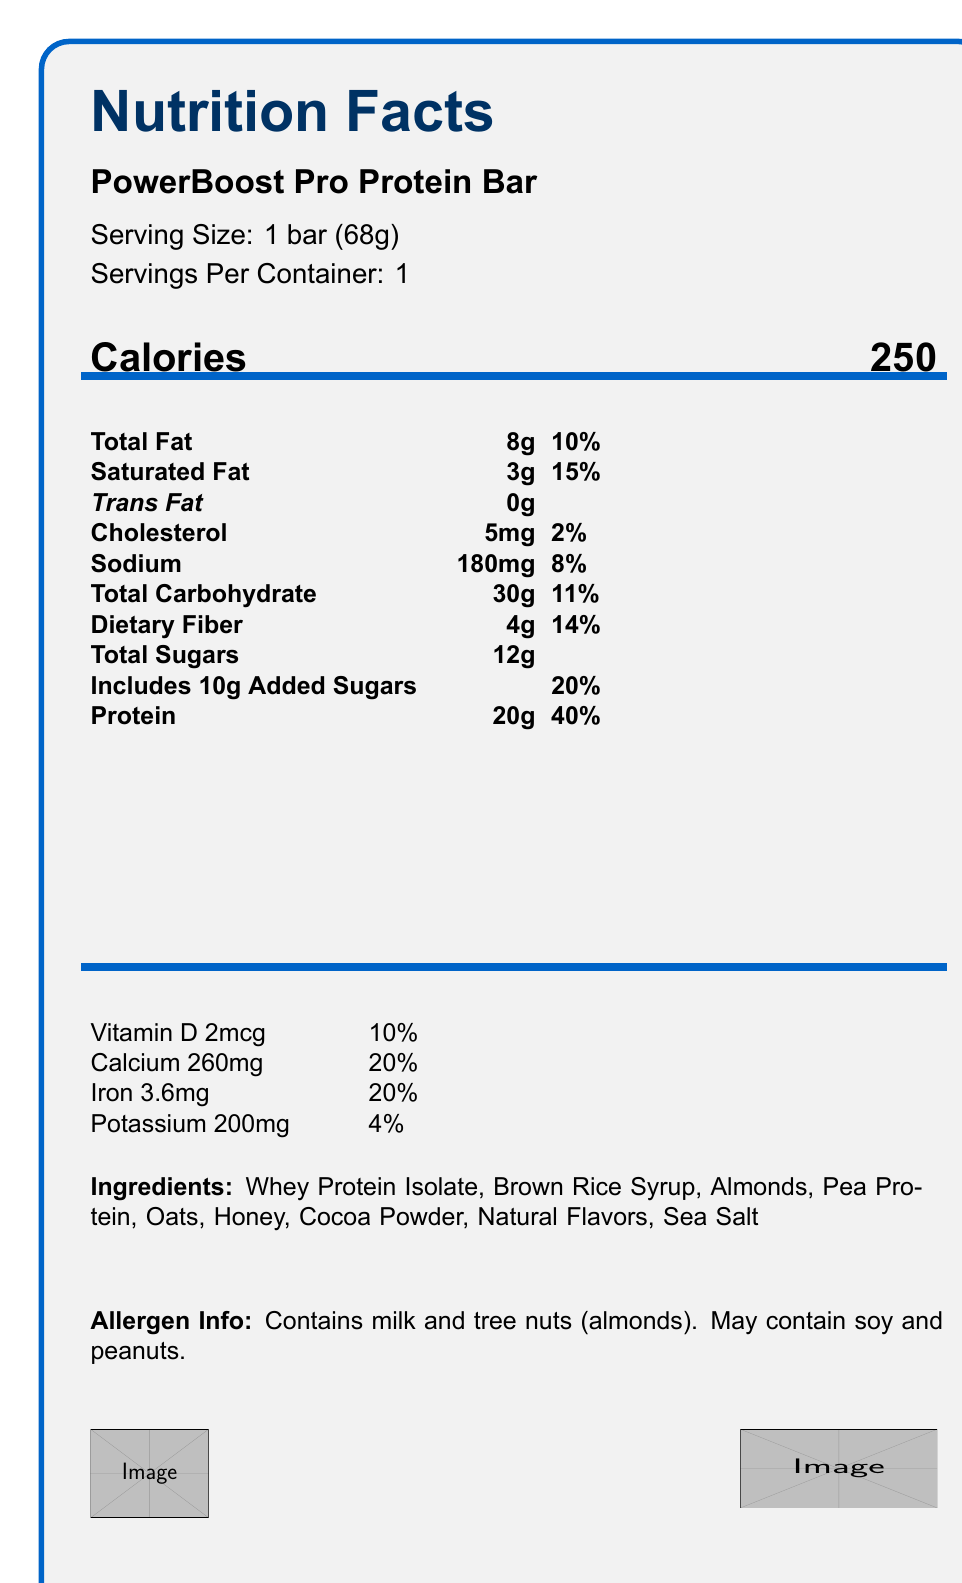What is the serving size of the PowerBoost Pro Protein Bar? The serving size is explicitly mentioned in the document as "Serving Size: 1 bar (68g)".
Answer: 1 bar (68g) How many calories are in one serving of the PowerBoost Pro Protein Bar? The number of calories per serving is listed next to the word "Calories" in the document.
Answer: 250 What is the amount of protein in one bar? The amount of protein is listed in the nutrients section as "Protein: 20g".
Answer: 20g Which vitamins and minerals are included in the nutrition facts? These are listed in the "Vitamins and Minerals" section along with their respective amounts and daily values.
Answer: Vitamin D, Calcium, Iron, Potassium What allergens are present in the PowerBoost Pro Protein Bar? The allergen information section mentions these ingredients explicitly.
Answer: Milk and tree nuts (almonds). May contain soy and peanuts. Which of the following nutrients has the highest daily value percentage? A. Sodium B. Calcium C. Protein D. Total Carbohydrate Protein has a daily value of 40%, which is higher than the other options provided.
Answer: C. Protein Which nutrient has the least amount per serving? A. Cholesterol B. Trans Fat C. Potassium D. Total Sugars Trans Fat is indicated as 0g, which is less than the other options.
Answer: B. Trans Fat Does the PowerBoost Pro Protein Bar contain any dietary fiber? Dietary Fiber is listed in the nutrient section as 4g.
Answer: Yes Is there any information about the barcode value? The barcode value is provided in the custom elements section as "123456789012".
Answer: Yes What is included in the "Ingredients" section? These ingredients are explicitly mentioned in the ingredients section.
Answer: Whey Protein Isolate, Brown Rice Syrup, Almonds, Pea Protein, Oats, Honey, Cocoa Powder, Natural Flavors, Sea Salt Is this document providing information about multiple products? The entire document focuses on the PowerBoost Pro Protein Bar.
Answer: No Summarize the main idea of the document. The document is a comprehensive nutrition label for a high-protein energy bar, providing information that includes calories, various nutrients, and allergens. It also includes custom rendering details with Skia, such as logo placement and barcode value.
Answer: The document provides a detailed nutrition facts label for the PowerBoost Pro Protein Bar, including serving size, calorie content, detailed nutrient information, vitamins and minerals, ingredients, allergen information, and some custom graphical elements. What are the rendering details for the logo image? The rendering details are found in the custom elements section that specify the position, size, and image path of the logo.
Answer: Position: (10, 10), Size: (50, 50), Image Path: "powerboost_logo.png" What technology has been used to render this document? The document doesn't provide explicit information on the technology used for rendering.
Answer: Not enough information What is the daily value percentage for Vitamin D? Vitamin D is listed in the "Vitamins and Minerals" section with a daily value percentage of 10%.
Answer: 10% What color is used for the thick bar below the calorie information? The color used for the thick bar is specified as "barcolor" in the LaTeX document, which corresponds to RGB(0,100,200).
Answer: barcolor or RGB(0,100,200) 